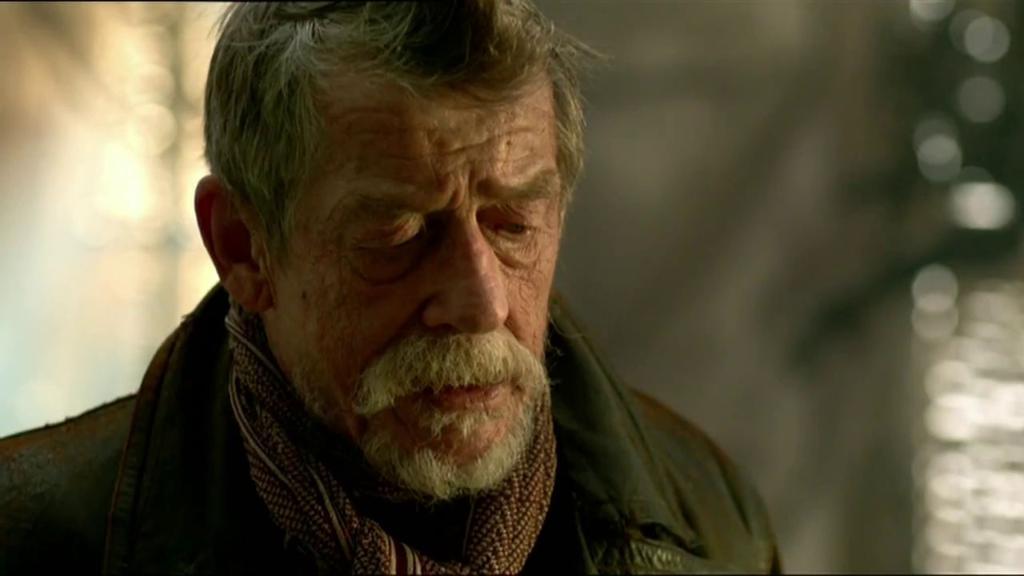How would you summarize this image in a sentence or two? In this image we can see a person and a blurry background. 